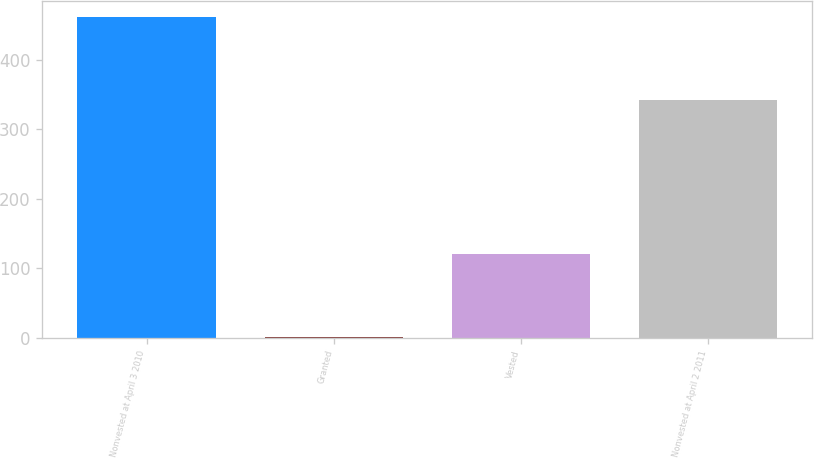Convert chart to OTSL. <chart><loc_0><loc_0><loc_500><loc_500><bar_chart><fcel>Nonvested at April 3 2010<fcel>Granted<fcel>Vested<fcel>Nonvested at April 2 2011<nl><fcel>462<fcel>1<fcel>121<fcel>342<nl></chart> 